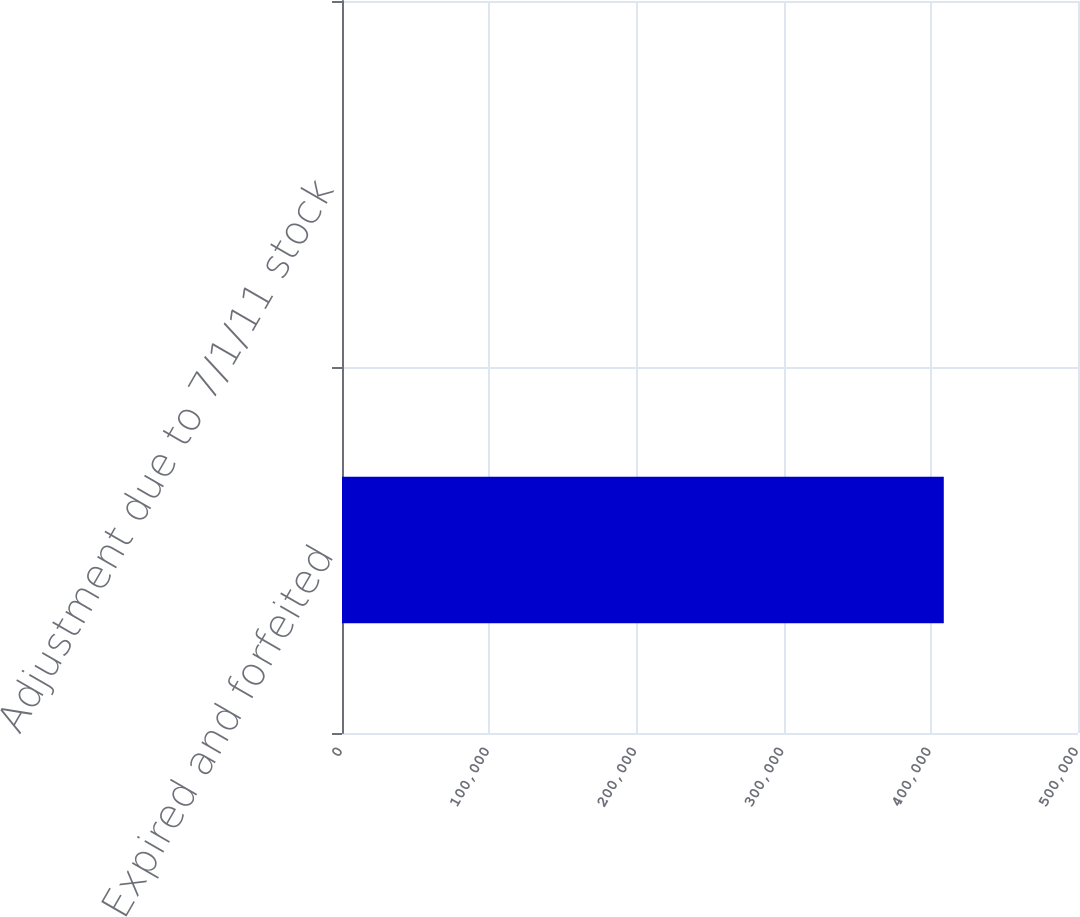<chart> <loc_0><loc_0><loc_500><loc_500><bar_chart><fcel>Expired and forfeited<fcel>Adjustment due to 7/1/11 stock<nl><fcel>408826<fcel>0.47<nl></chart> 